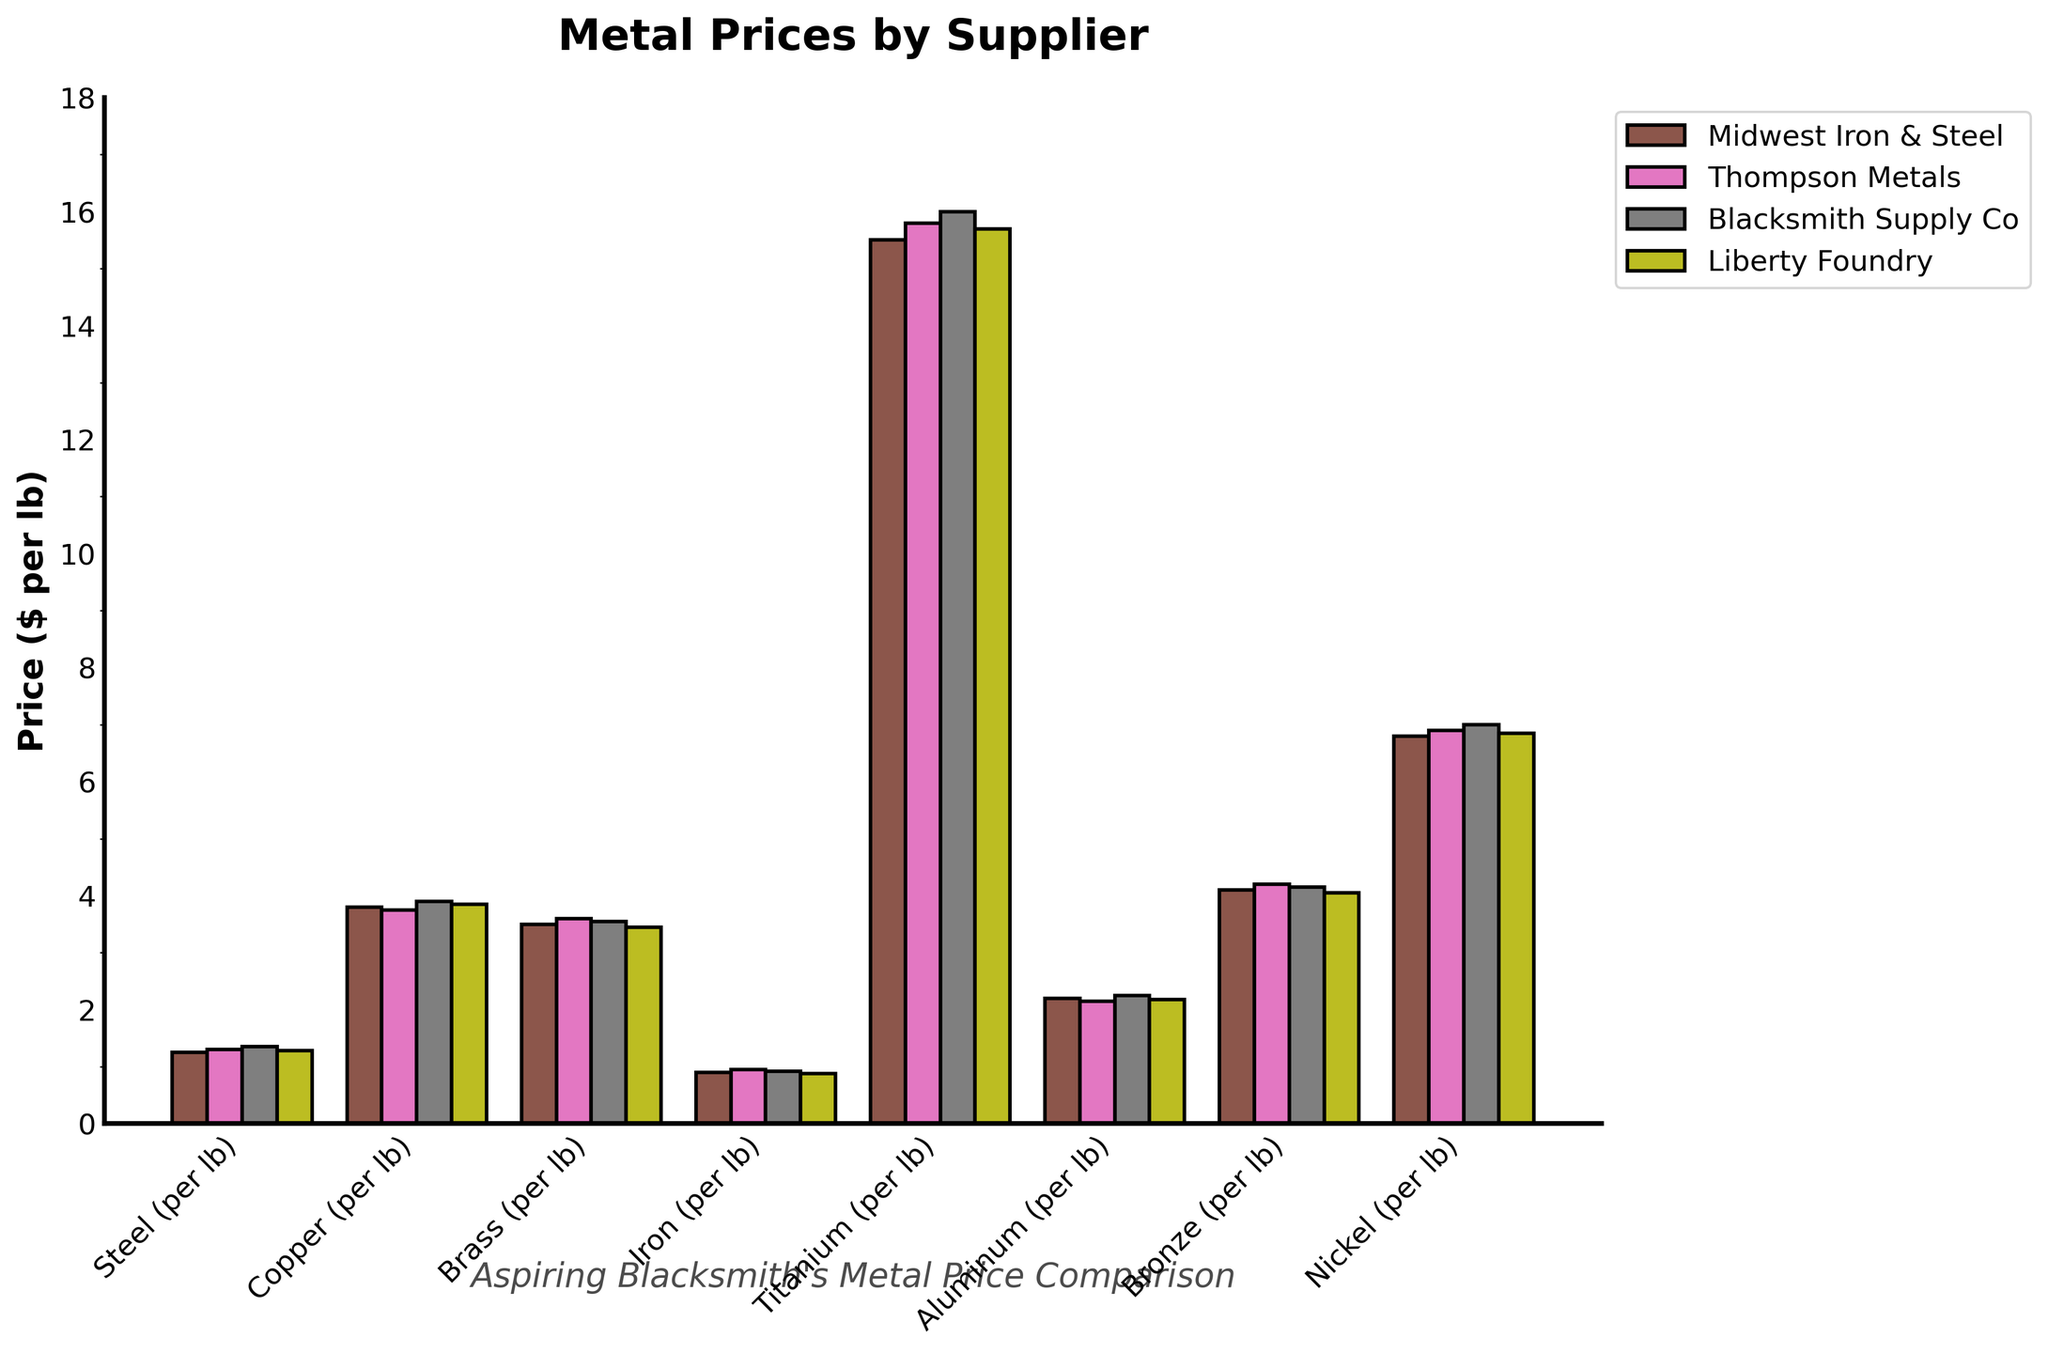What is the highest price of titanium across all suppliers? To determine the highest price of titanium across all suppliers, locate the titanium bar for each supplier and identify the tallest bar, which visually represents the highest price. The prices are $15.50, $15.80, $16.00, and $15.70. Among these, $16.00 is the highest.
Answer: $16.00 Which supplier offers the cheapest price for aluminum? Examine the aluminum bars for each supplier. The prices are $2.20, $2.15, $2.25, and $2.18. Among these, $2.15 is the lowest, which is offered by Thompson Metals.
Answer: Thompson Metals What is the difference in price for steel between Midwest Iron & Steel and Blacksmith Supply Co.? First, find the prices of steel for Midwest Iron & Steel and Blacksmith Supply Co., which are $1.25 and $1.35, respectively. The difference is $1.35 - $1.25 = $0.10.
Answer: $0.10 Which metal has the greatest price difference between the suppliers? Compare the price ranges for each metal by looking at the differences between the highest and lowest prices. For titanium, the range is $16.00 - $15.50 = $0.50. Calculating similarly for the other metals: Steel ($1.35 - $1.25 = $0.10), Copper ($3.90 - $3.75 = $0.15), Brass ($3.60 - $3.45 = $0.15), Iron ($0.95 - $0.88 = $0.07), Aluminum ($2.25 - $2.15 = $0.10), Bronze ($4.20 - $4.05 = $0.15), Nickel ($7.00 - $6.80 = $0.20). Titanium has the greatest price difference.
Answer: Titanium What is the average price of copper across all suppliers? Find the prices of copper for all suppliers: $3.80, $3.75, $3.90, and $3.85. The average is calculated as (3.80 + 3.75 + 3.90 + 3.85) / 4 = 3.825.
Answer: $3.83 